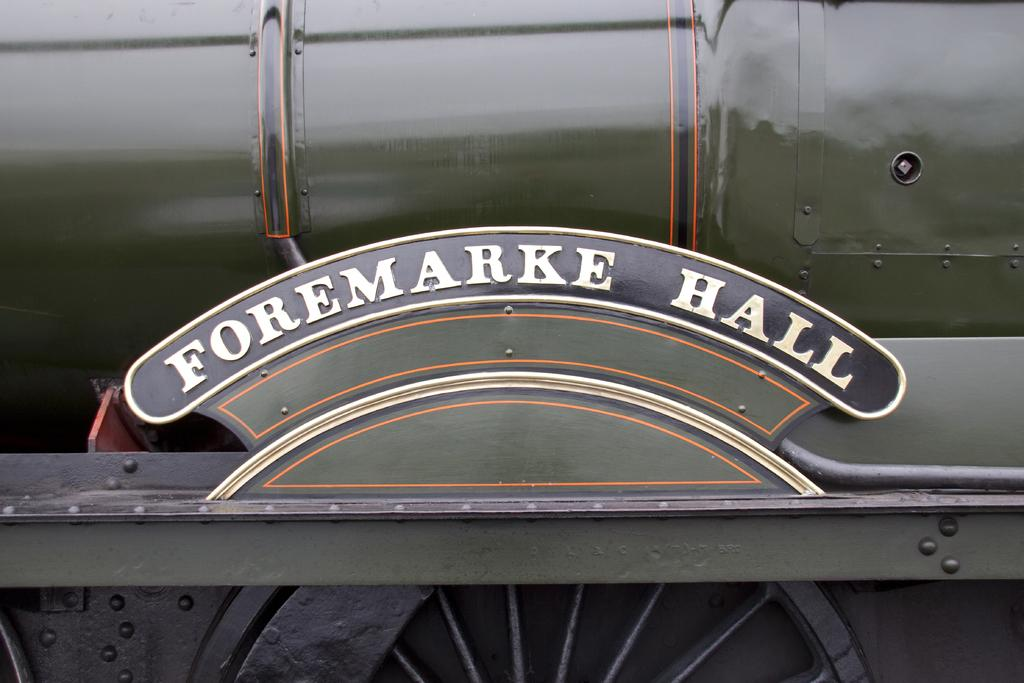What is the main subject of the image? The main subject of the image is a train. What color is the train? The train is green in color. What part of the train is visible at the bottom? There is a wheel at the bottom of the train. What is present at the front of the train? There is a name board in the front of the train. Where is the scarecrow standing next to the train in the image? There is no scarecrow present in the image. What type of grain is being transported by the train in the image? The image does not show any grain being transported by the train. 